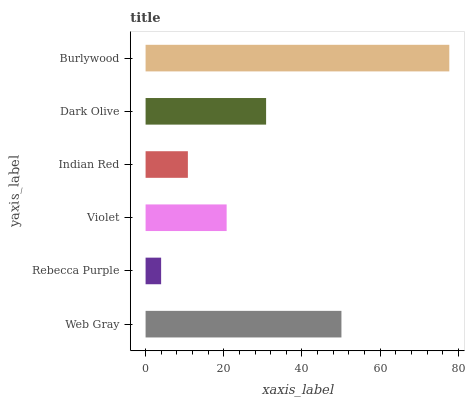Is Rebecca Purple the minimum?
Answer yes or no. Yes. Is Burlywood the maximum?
Answer yes or no. Yes. Is Violet the minimum?
Answer yes or no. No. Is Violet the maximum?
Answer yes or no. No. Is Violet greater than Rebecca Purple?
Answer yes or no. Yes. Is Rebecca Purple less than Violet?
Answer yes or no. Yes. Is Rebecca Purple greater than Violet?
Answer yes or no. No. Is Violet less than Rebecca Purple?
Answer yes or no. No. Is Dark Olive the high median?
Answer yes or no. Yes. Is Violet the low median?
Answer yes or no. Yes. Is Violet the high median?
Answer yes or no. No. Is Dark Olive the low median?
Answer yes or no. No. 